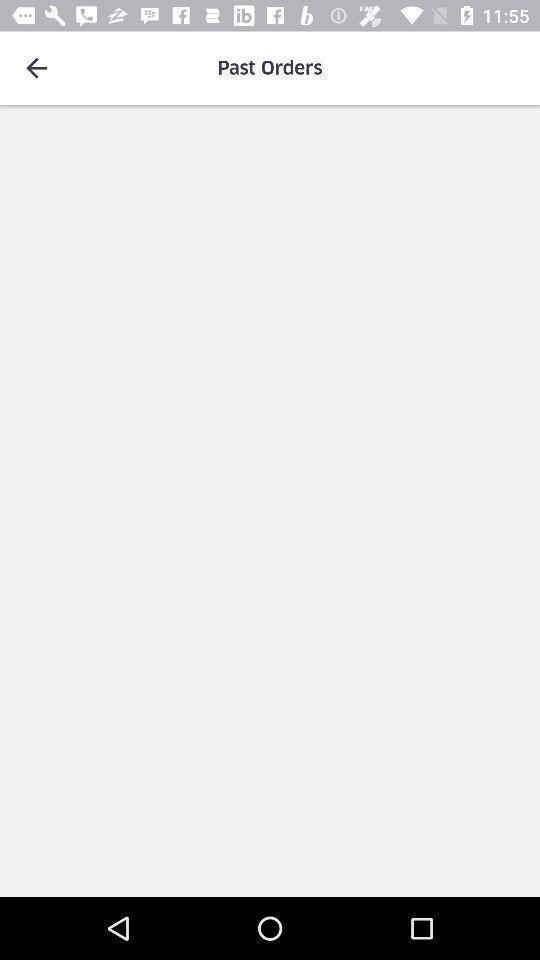What details can you identify in this image? Screen showing blank page on past orders. 